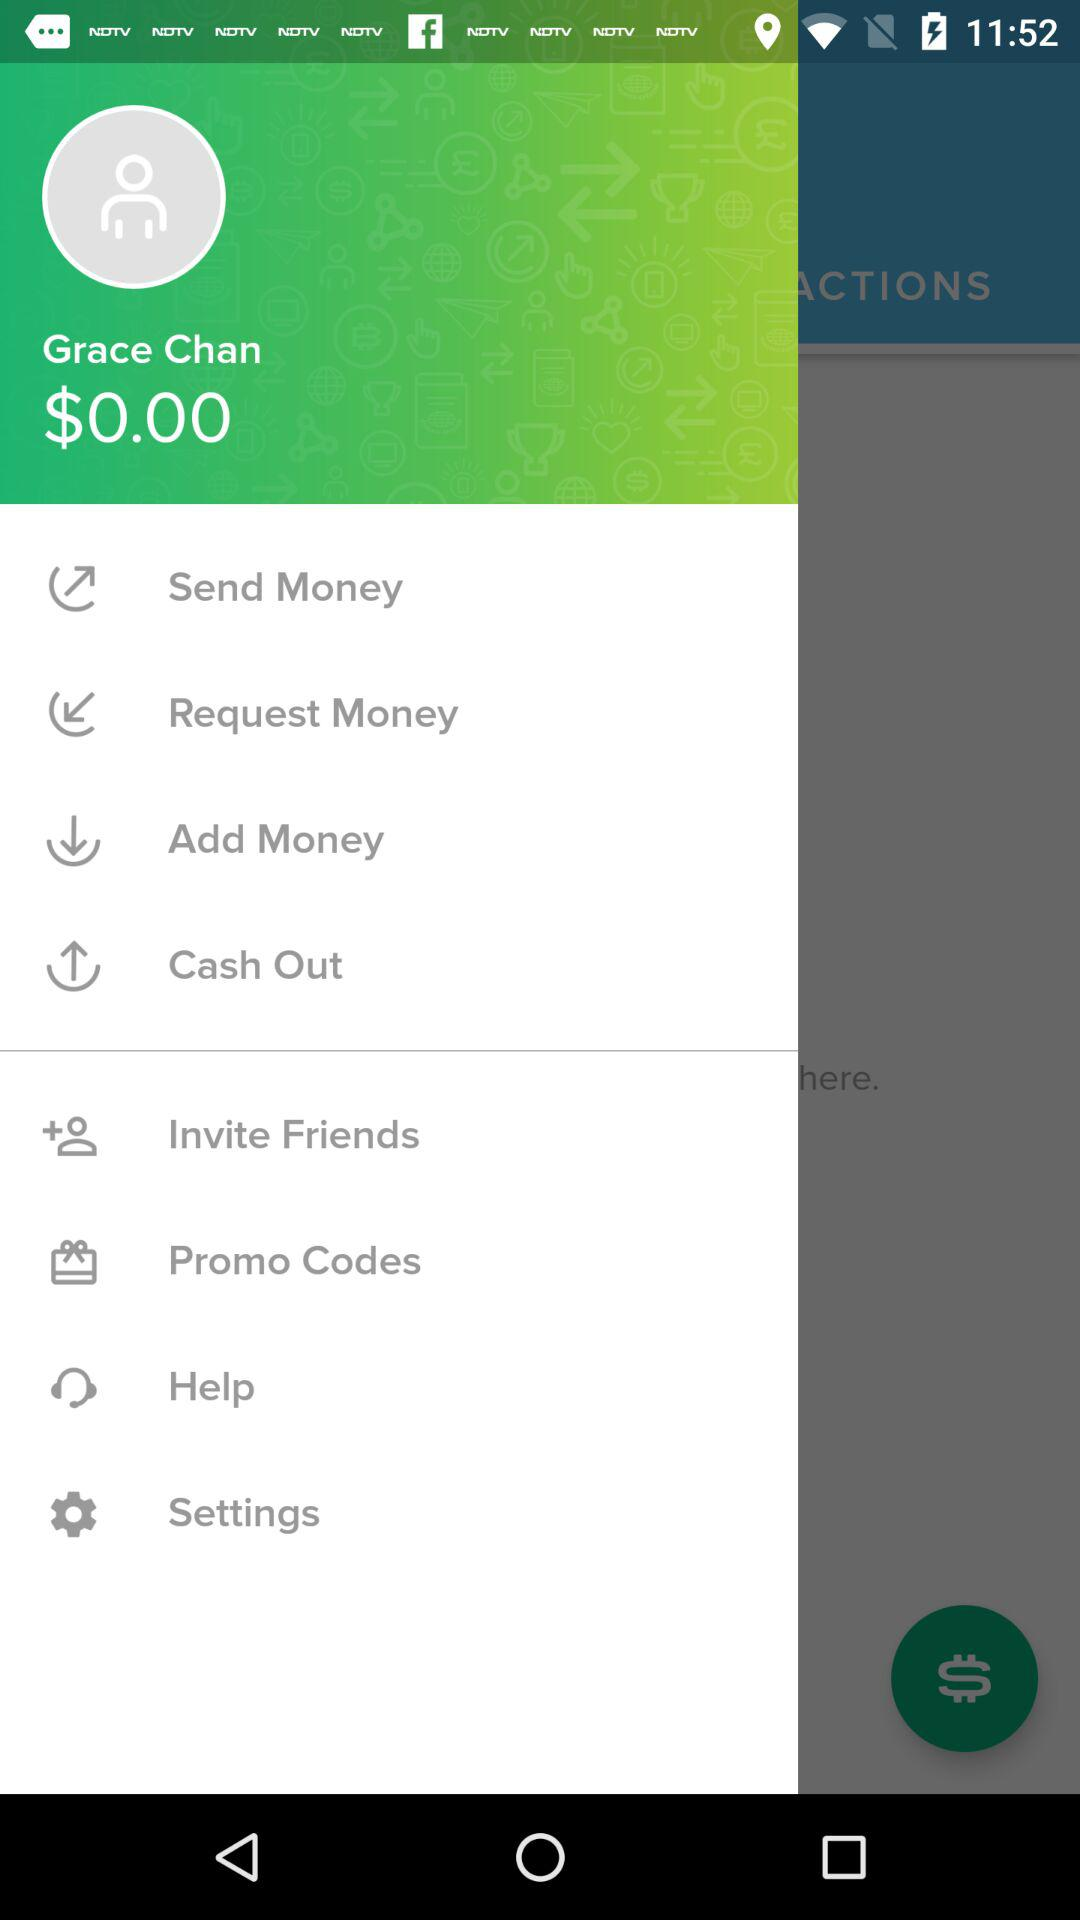How many dollars do I have?
Answer the question using a single word or phrase. $0.00 